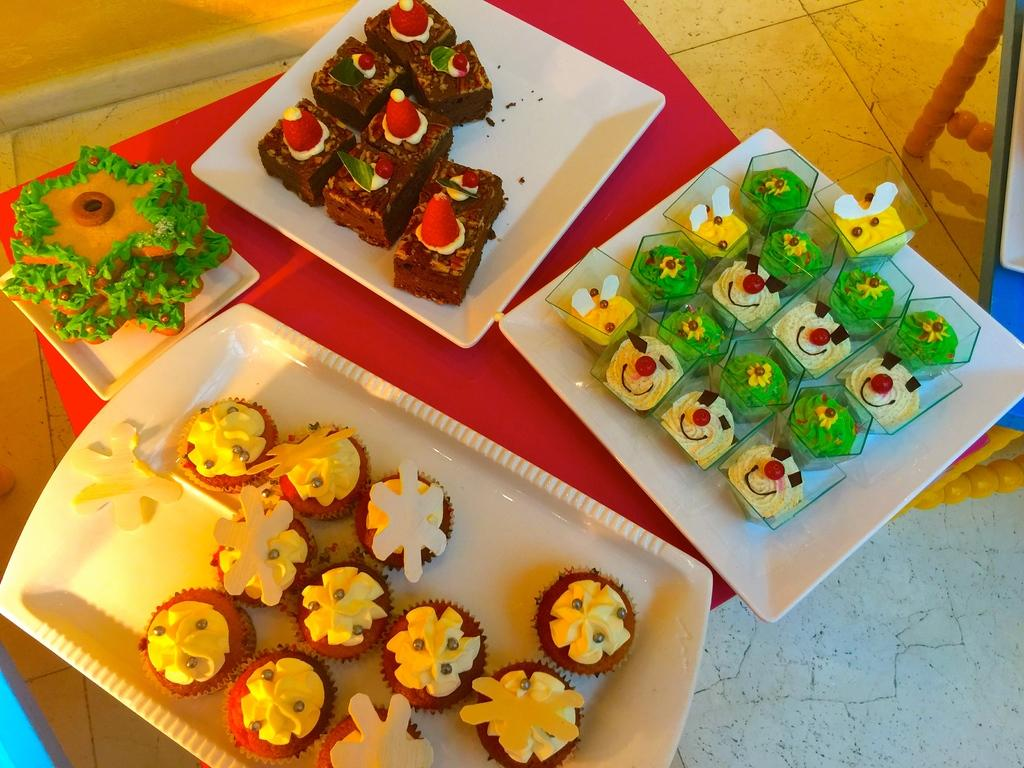What type of desserts can be seen in the image? There are cupcakes and cakes in the image. How are the cupcakes and cakes arranged in the image? The cupcakes and cakes are placed on plates and a platter. Where are the plates and platter located? They are on a table in the image. Can you describe the setting in the image? There is another table on the right side of the image, and the floor is visible at the bottom of the image. What type of lettuce is being used to decorate the cakes in the image? There is no lettuce present in the image; the desserts are cupcakes and cakes, not salads. 